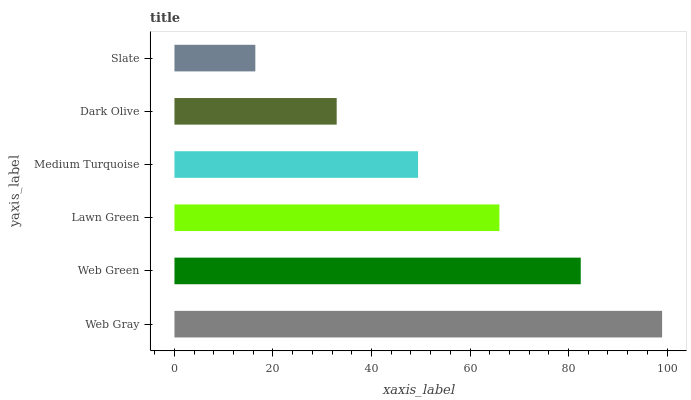Is Slate the minimum?
Answer yes or no. Yes. Is Web Gray the maximum?
Answer yes or no. Yes. Is Web Green the minimum?
Answer yes or no. No. Is Web Green the maximum?
Answer yes or no. No. Is Web Gray greater than Web Green?
Answer yes or no. Yes. Is Web Green less than Web Gray?
Answer yes or no. Yes. Is Web Green greater than Web Gray?
Answer yes or no. No. Is Web Gray less than Web Green?
Answer yes or no. No. Is Lawn Green the high median?
Answer yes or no. Yes. Is Medium Turquoise the low median?
Answer yes or no. Yes. Is Web Gray the high median?
Answer yes or no. No. Is Lawn Green the low median?
Answer yes or no. No. 